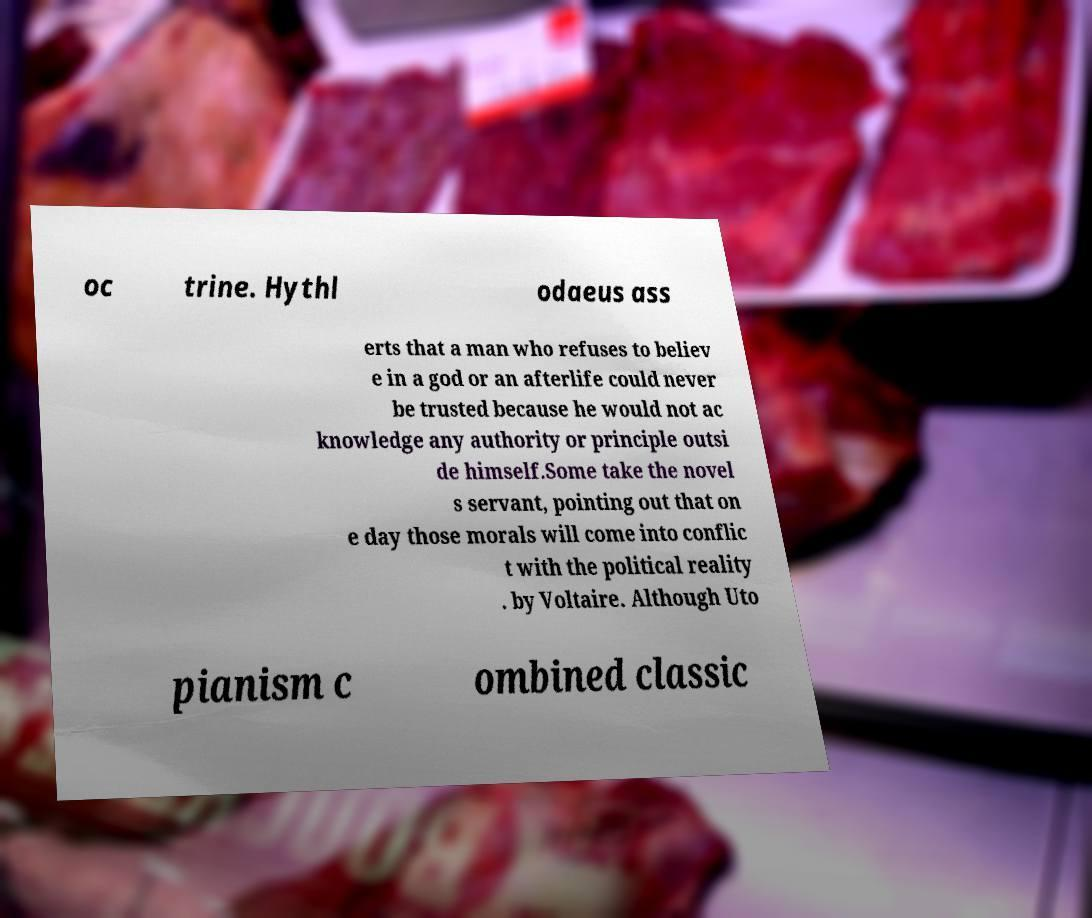Please read and relay the text visible in this image. What does it say? oc trine. Hythl odaeus ass erts that a man who refuses to believ e in a god or an afterlife could never be trusted because he would not ac knowledge any authority or principle outsi de himself.Some take the novel s servant, pointing out that on e day those morals will come into conflic t with the political reality . by Voltaire. Although Uto pianism c ombined classic 